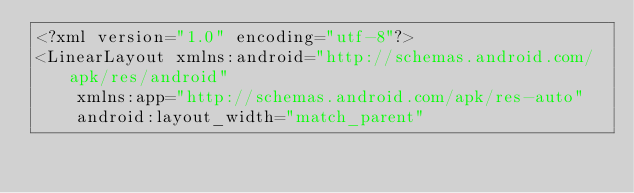Convert code to text. <code><loc_0><loc_0><loc_500><loc_500><_XML_><?xml version="1.0" encoding="utf-8"?>
<LinearLayout xmlns:android="http://schemas.android.com/apk/res/android"
    xmlns:app="http://schemas.android.com/apk/res-auto"
    android:layout_width="match_parent"</code> 